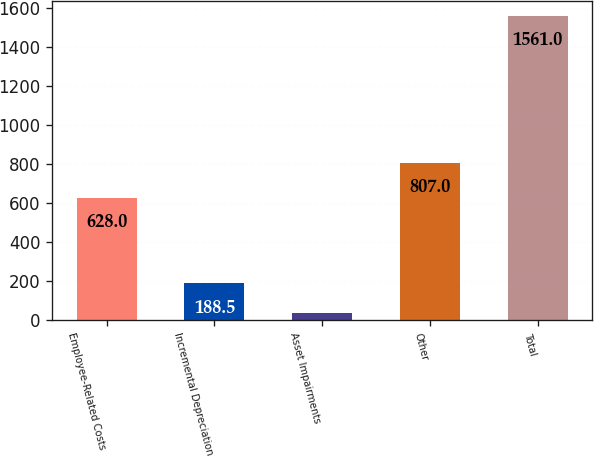<chart> <loc_0><loc_0><loc_500><loc_500><bar_chart><fcel>Employee-Related Costs<fcel>Incremental Depreciation<fcel>Asset Impairments<fcel>Other<fcel>Total<nl><fcel>628<fcel>188.5<fcel>36<fcel>807<fcel>1561<nl></chart> 